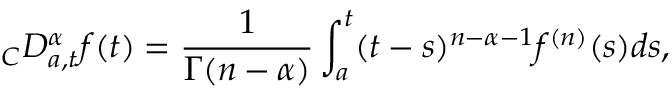<formula> <loc_0><loc_0><loc_500><loc_500>\ _ { C } D _ { a , t } ^ { \alpha } f ( t ) = \frac { 1 } { \Gamma ( n - \alpha ) } \int _ { a } ^ { t } ( t - s ) ^ { n - \alpha - 1 } f ^ { ( n ) } ( s ) d s ,</formula> 